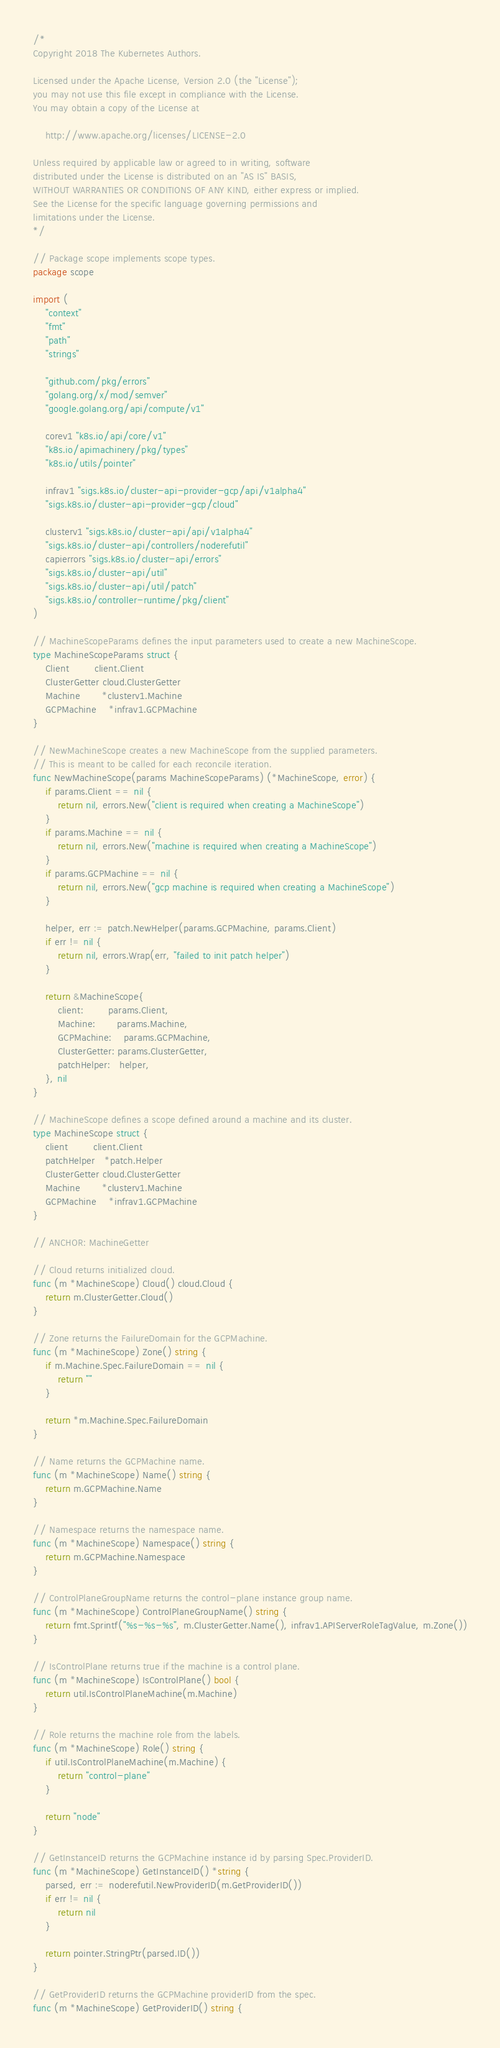<code> <loc_0><loc_0><loc_500><loc_500><_Go_>/*
Copyright 2018 The Kubernetes Authors.

Licensed under the Apache License, Version 2.0 (the "License");
you may not use this file except in compliance with the License.
You may obtain a copy of the License at

    http://www.apache.org/licenses/LICENSE-2.0

Unless required by applicable law or agreed to in writing, software
distributed under the License is distributed on an "AS IS" BASIS,
WITHOUT WARRANTIES OR CONDITIONS OF ANY KIND, either express or implied.
See the License for the specific language governing permissions and
limitations under the License.
*/

// Package scope implements scope types.
package scope

import (
	"context"
	"fmt"
	"path"
	"strings"

	"github.com/pkg/errors"
	"golang.org/x/mod/semver"
	"google.golang.org/api/compute/v1"

	corev1 "k8s.io/api/core/v1"
	"k8s.io/apimachinery/pkg/types"
	"k8s.io/utils/pointer"

	infrav1 "sigs.k8s.io/cluster-api-provider-gcp/api/v1alpha4"
	"sigs.k8s.io/cluster-api-provider-gcp/cloud"

	clusterv1 "sigs.k8s.io/cluster-api/api/v1alpha4"
	"sigs.k8s.io/cluster-api/controllers/noderefutil"
	capierrors "sigs.k8s.io/cluster-api/errors"
	"sigs.k8s.io/cluster-api/util"
	"sigs.k8s.io/cluster-api/util/patch"
	"sigs.k8s.io/controller-runtime/pkg/client"
)

// MachineScopeParams defines the input parameters used to create a new MachineScope.
type MachineScopeParams struct {
	Client        client.Client
	ClusterGetter cloud.ClusterGetter
	Machine       *clusterv1.Machine
	GCPMachine    *infrav1.GCPMachine
}

// NewMachineScope creates a new MachineScope from the supplied parameters.
// This is meant to be called for each reconcile iteration.
func NewMachineScope(params MachineScopeParams) (*MachineScope, error) {
	if params.Client == nil {
		return nil, errors.New("client is required when creating a MachineScope")
	}
	if params.Machine == nil {
		return nil, errors.New("machine is required when creating a MachineScope")
	}
	if params.GCPMachine == nil {
		return nil, errors.New("gcp machine is required when creating a MachineScope")
	}

	helper, err := patch.NewHelper(params.GCPMachine, params.Client)
	if err != nil {
		return nil, errors.Wrap(err, "failed to init patch helper")
	}

	return &MachineScope{
		client:        params.Client,
		Machine:       params.Machine,
		GCPMachine:    params.GCPMachine,
		ClusterGetter: params.ClusterGetter,
		patchHelper:   helper,
	}, nil
}

// MachineScope defines a scope defined around a machine and its cluster.
type MachineScope struct {
	client        client.Client
	patchHelper   *patch.Helper
	ClusterGetter cloud.ClusterGetter
	Machine       *clusterv1.Machine
	GCPMachine    *infrav1.GCPMachine
}

// ANCHOR: MachineGetter

// Cloud returns initialized cloud.
func (m *MachineScope) Cloud() cloud.Cloud {
	return m.ClusterGetter.Cloud()
}

// Zone returns the FailureDomain for the GCPMachine.
func (m *MachineScope) Zone() string {
	if m.Machine.Spec.FailureDomain == nil {
		return ""
	}

	return *m.Machine.Spec.FailureDomain
}

// Name returns the GCPMachine name.
func (m *MachineScope) Name() string {
	return m.GCPMachine.Name
}

// Namespace returns the namespace name.
func (m *MachineScope) Namespace() string {
	return m.GCPMachine.Namespace
}

// ControlPlaneGroupName returns the control-plane instance group name.
func (m *MachineScope) ControlPlaneGroupName() string {
	return fmt.Sprintf("%s-%s-%s", m.ClusterGetter.Name(), infrav1.APIServerRoleTagValue, m.Zone())
}

// IsControlPlane returns true if the machine is a control plane.
func (m *MachineScope) IsControlPlane() bool {
	return util.IsControlPlaneMachine(m.Machine)
}

// Role returns the machine role from the labels.
func (m *MachineScope) Role() string {
	if util.IsControlPlaneMachine(m.Machine) {
		return "control-plane"
	}

	return "node"
}

// GetInstanceID returns the GCPMachine instance id by parsing Spec.ProviderID.
func (m *MachineScope) GetInstanceID() *string {
	parsed, err := noderefutil.NewProviderID(m.GetProviderID())
	if err != nil {
		return nil
	}

	return pointer.StringPtr(parsed.ID())
}

// GetProviderID returns the GCPMachine providerID from the spec.
func (m *MachineScope) GetProviderID() string {</code> 